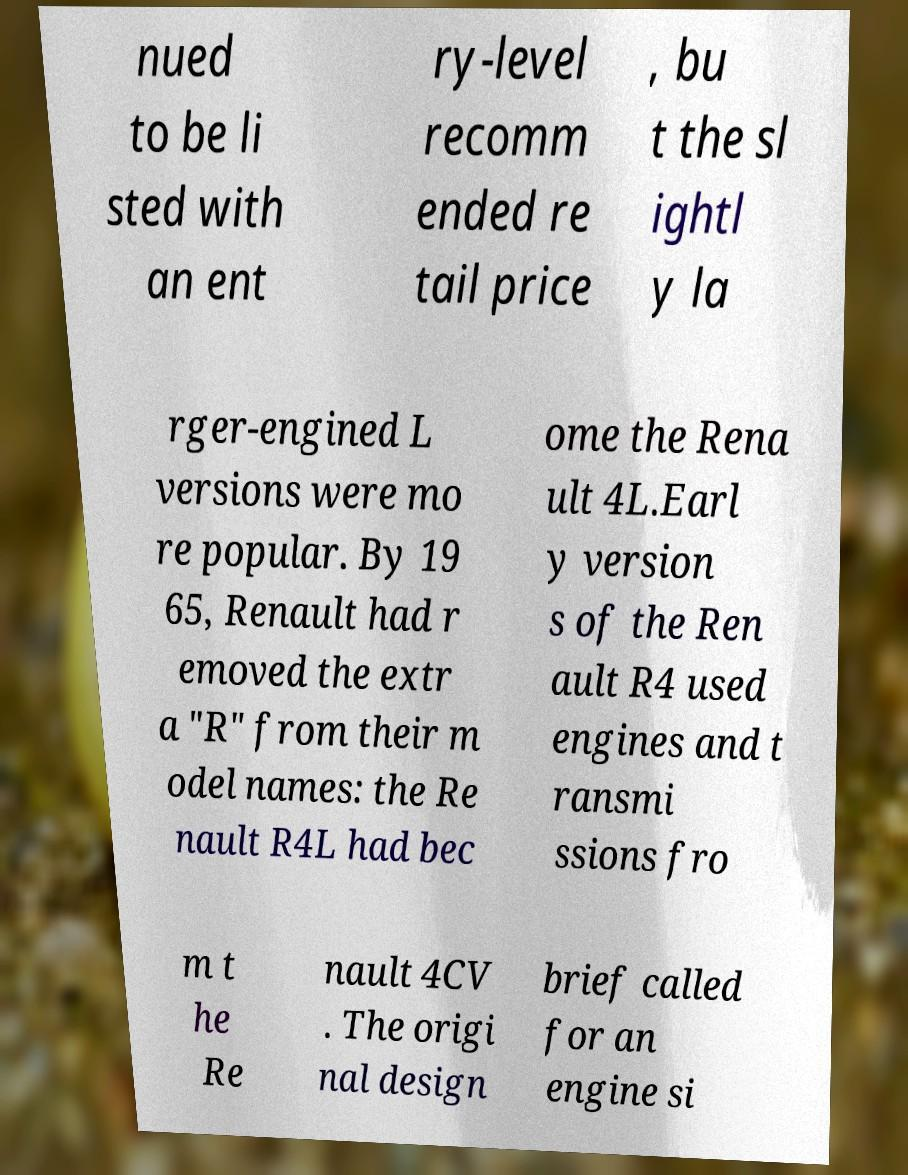Could you assist in decoding the text presented in this image and type it out clearly? nued to be li sted with an ent ry-level recomm ended re tail price , bu t the sl ightl y la rger-engined L versions were mo re popular. By 19 65, Renault had r emoved the extr a "R" from their m odel names: the Re nault R4L had bec ome the Rena ult 4L.Earl y version s of the Ren ault R4 used engines and t ransmi ssions fro m t he Re nault 4CV . The origi nal design brief called for an engine si 